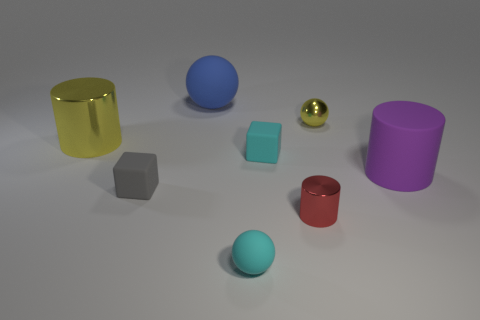Subtract 1 spheres. How many spheres are left? 2 Subtract all matte balls. How many balls are left? 1 Add 1 blue metallic balls. How many objects exist? 9 Subtract all blocks. How many objects are left? 6 Subtract 0 blue blocks. How many objects are left? 8 Subtract all rubber cubes. Subtract all gray matte things. How many objects are left? 5 Add 1 yellow shiny objects. How many yellow shiny objects are left? 3 Add 4 large purple blocks. How many large purple blocks exist? 4 